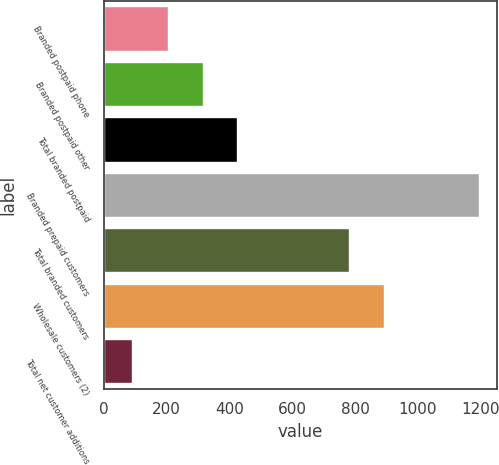Convert chart. <chart><loc_0><loc_0><loc_500><loc_500><bar_chart><fcel>Branded postpaid phone<fcel>Branded postpaid other<fcel>Total branded postpaid<fcel>Branded prepaid customers<fcel>Total branded customers<fcel>Wholesale customers (2)<fcel>Total net customer additions<nl><fcel>204<fcel>314.2<fcel>424.4<fcel>1193<fcel>780<fcel>890.2<fcel>91<nl></chart> 